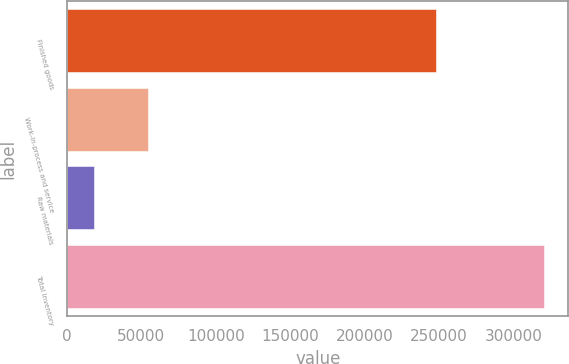<chart> <loc_0><loc_0><loc_500><loc_500><bar_chart><fcel>Finished goods<fcel>Work-in-process and service<fcel>Raw materials<fcel>Total inventory<nl><fcel>248233<fcel>54455<fcel>18320<fcel>321008<nl></chart> 